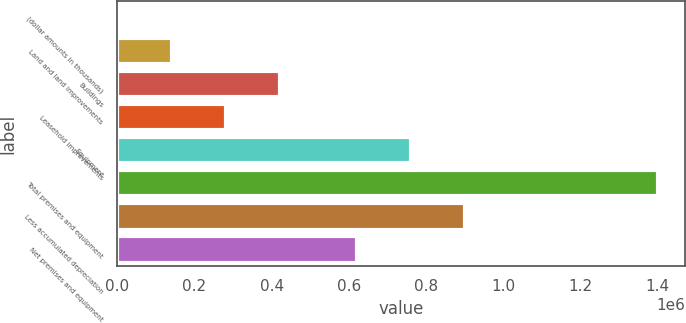<chart> <loc_0><loc_0><loc_500><loc_500><bar_chart><fcel>(dollar amounts in thousands)<fcel>Land and land improvements<fcel>Buildings<fcel>Leasehold improvements<fcel>Equipment<fcel>Total premises and equipment<fcel>Less accumulated depreciation<fcel>Net premises and equipment<nl><fcel>2015<fcel>141950<fcel>421821<fcel>281886<fcel>760475<fcel>1.40137e+06<fcel>900411<fcel>620540<nl></chart> 